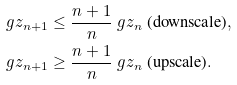<formula> <loc_0><loc_0><loc_500><loc_500>\ g z _ { n + 1 } & \leq \frac { n + 1 } { n } \ g z _ { n } \text { (downscale)} , \\ \ g z _ { n + 1 } & \geq \frac { n + 1 } { n } \ g z _ { n } \text { (upscale)} .</formula> 